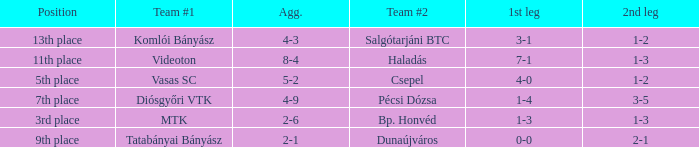How many positions correspond to a 1-3 1st leg? 1.0. 